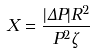Convert formula to latex. <formula><loc_0><loc_0><loc_500><loc_500>X = \frac { | \Delta P | R ^ { 2 } } { P ^ { 2 } \zeta }</formula> 